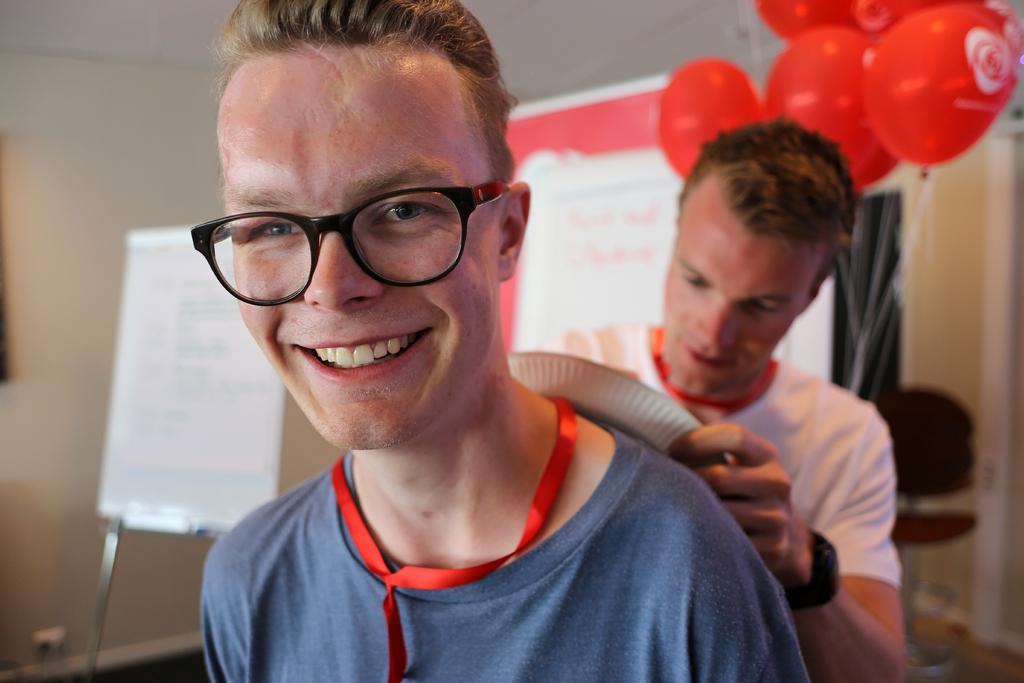How many people are present in the image? There are two people standing in the image. What are the people holding? The people are holding something, but the facts do not specify what it is. What can be seen in the background of the image? There are red balloons, a whiteboard, and a wall in the background. How many mice are running on the wall in the image? There are no mice present in the image; the facts only mention a wall in the background. 